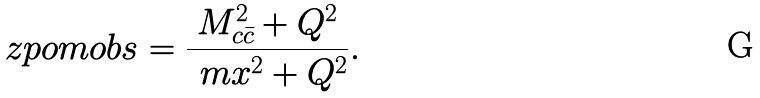<formula> <loc_0><loc_0><loc_500><loc_500>\ z p o m o b s = \frac { M _ { c \bar { c } } ^ { 2 } + Q ^ { 2 } } { \ m x ^ { 2 } + Q ^ { 2 } } .</formula> 